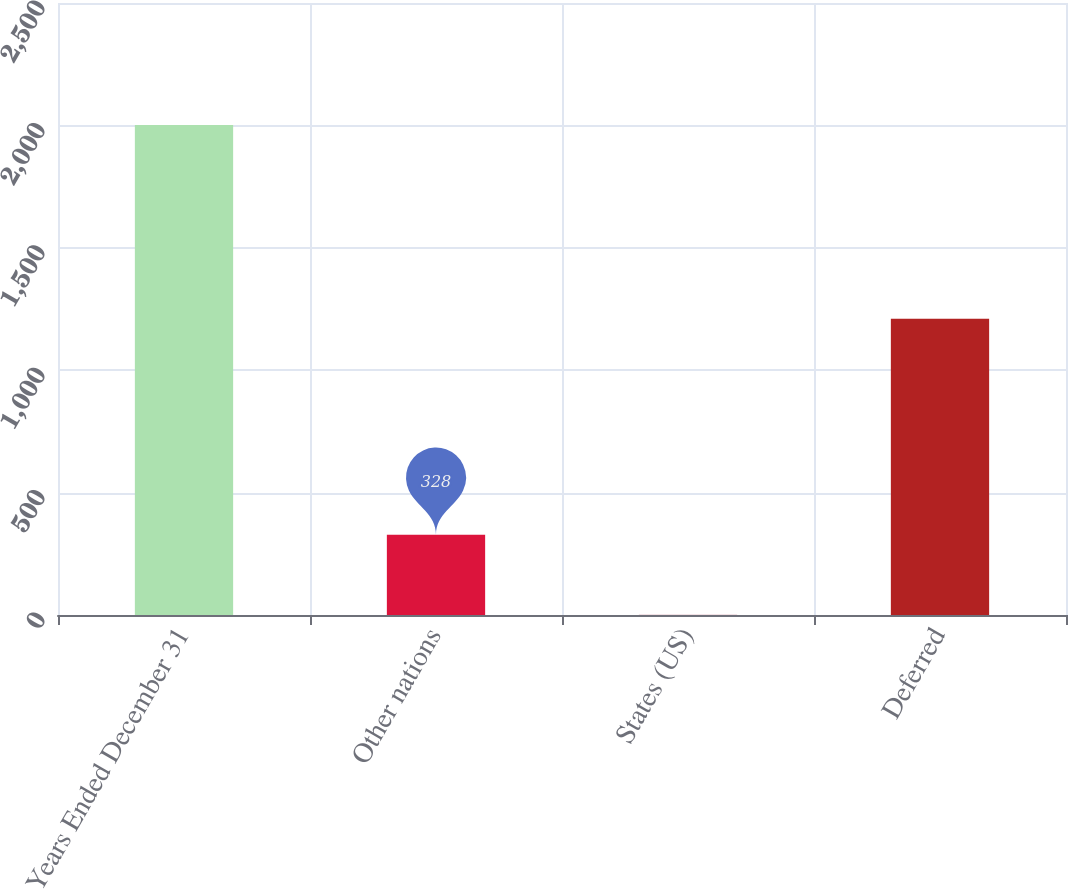<chart> <loc_0><loc_0><loc_500><loc_500><bar_chart><fcel>Years Ended December 31<fcel>Other nations<fcel>States (US)<fcel>Deferred<nl><fcel>2002<fcel>328<fcel>1<fcel>1210<nl></chart> 